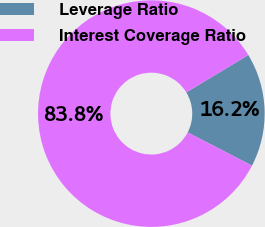Convert chart to OTSL. <chart><loc_0><loc_0><loc_500><loc_500><pie_chart><fcel>Leverage Ratio<fcel>Interest Coverage Ratio<nl><fcel>16.25%<fcel>83.75%<nl></chart> 